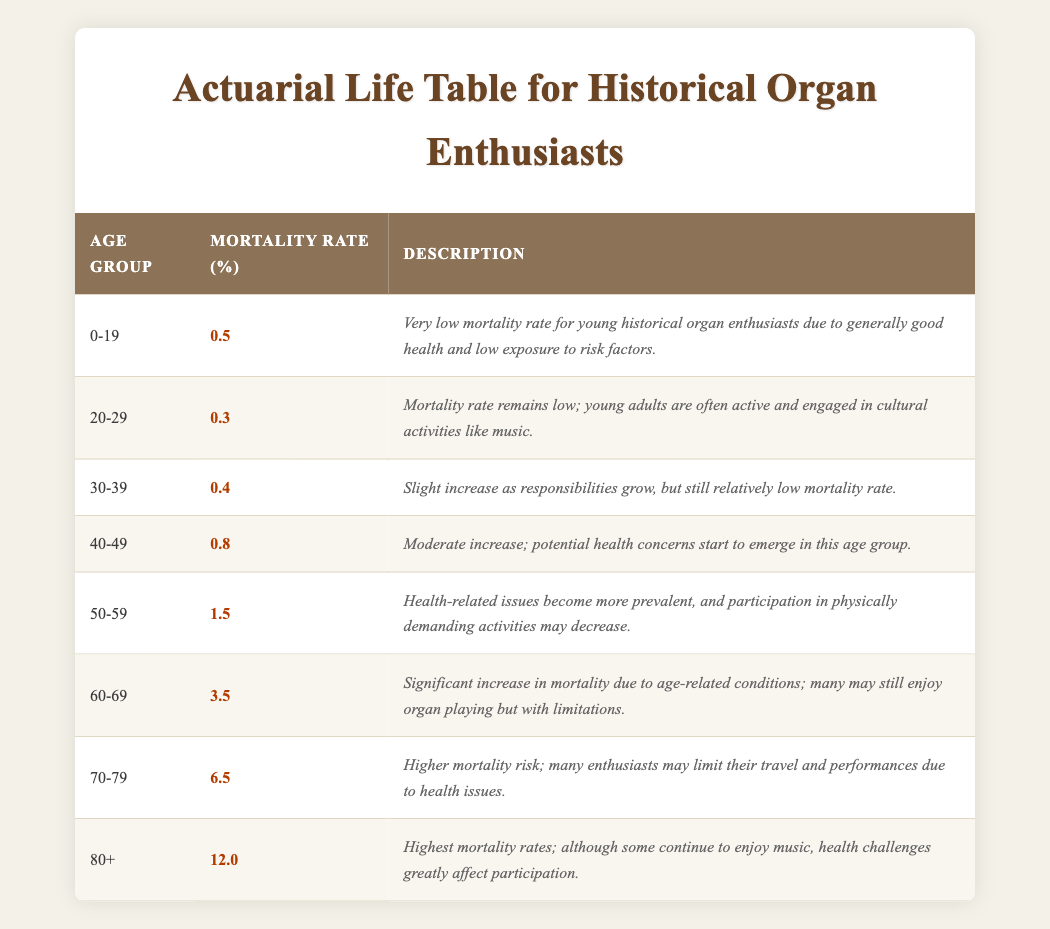What's the mortality rate for the age group 40-49? The table lists the mortality rate for the age group 40-49 as 0.8%.
Answer: 0.8% What age group has the highest mortality rate? The table shows that the age group 80+ has the highest mortality rate at 12.0%.
Answer: 80+ Is the mortality rate for ages 20-29 higher than that for ages 30-39? The mortality rate for ages 20-29 is 0.3%, while for ages 30-39 it is 0.4%. Since 0.3% is not higher than 0.4%, the answer is no.
Answer: No What is the average mortality rate for the age groups 50-59 and 60-69? The mortality rates for the age groups 50-59 and 60-69 are 1.5% and 3.5%, respectively. To find the average, add the two rates (1.5 + 3.5 = 5.0) and divide by 2, which equals 2.5%.
Answer: 2.5% Has the mortality rate increased or decreased from age group 30-39 to 40-49? The mortality rate for the age group 30-39 is 0.4%, while it rises to 0.8% for the age group 40-49. Since 0.8% is greater than 0.4%, it has increased.
Answer: Increased What is the total mortality rate for age groups 70-79 and 80+? The mortality rates for the age group 70-79 is 6.5% and for age group 80+ is 12.0%. Adding these together (6.5 + 12.0 = 18.5) gives the total mortality rate for these two age groups.
Answer: 18.5% Are health challenges less impactful on historical organ players in the age group 20-29 compared to those in the age group 60-69? The description for 20-29 mentions low mortality and good health, while 60-69 notes significant mortality increases due to age-related conditions. Therefore, health challenges are indeed less impactful for 20-29 than for 60-69.
Answer: Yes Which age group experiences a moderate increase in mortality rates? The age group 40-49 experiences a moderate increase in mortality rates as indicated in the description associated with that group.
Answer: 40-49 How does the mortality rate for ages 60-69 compare to that for ages 50-59? The mortality rate for ages 60-69 is 3.5%, while for ages 50-59 it is 1.5%. The rate for ages 60-69 is higher than that for ages 50-59, indicating that mortality increases with age.
Answer: Higher 